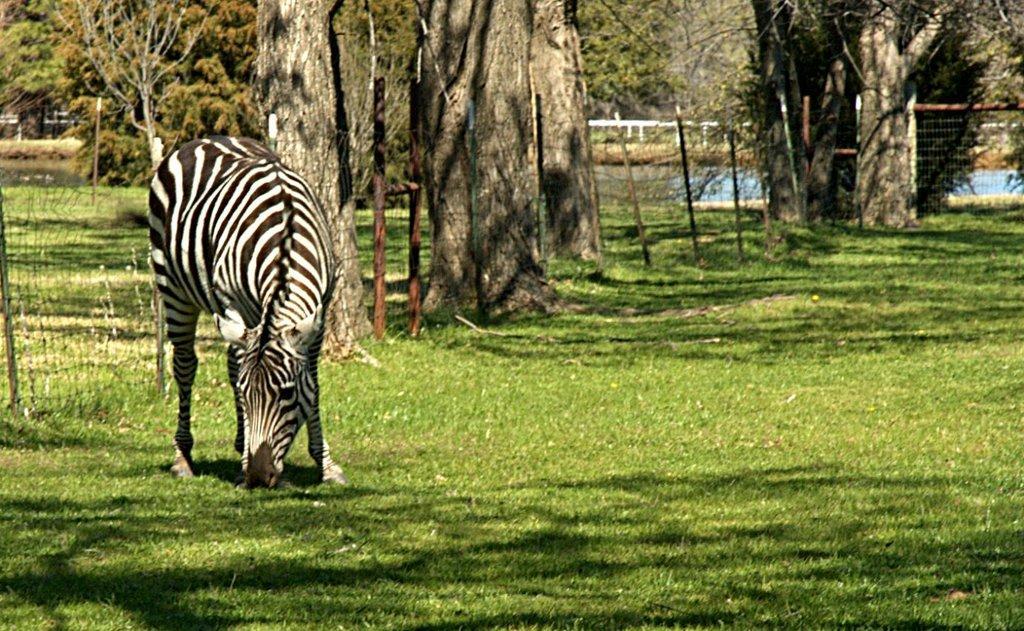How would you summarize this image in a sentence or two? In the picture I can see a zebra is standing on the ground. In the background I can see fence, trees, the grass, the water and some other objects. 